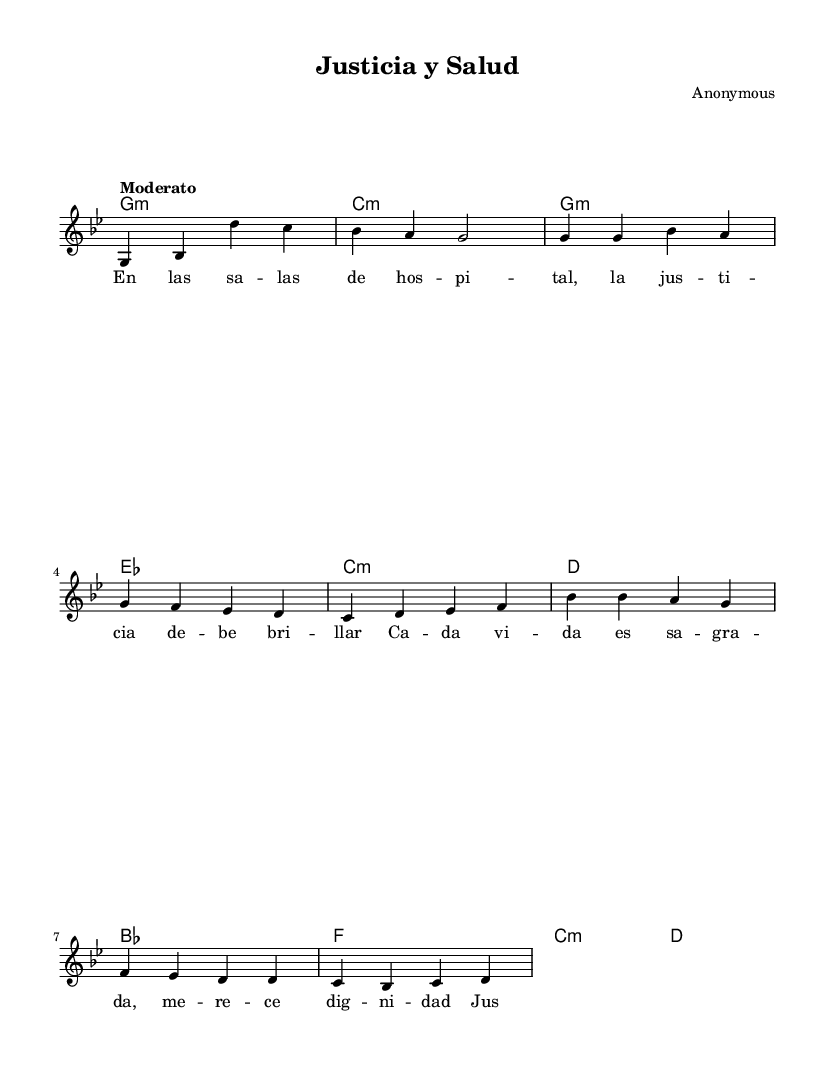What is the key signature of this music? The key signature is G minor, which has two flats (B flat and E flat) indicated right after the clef sign. This is confirmed by the "g" at the start of the global settings.
Answer: G minor What is the time signature of this piece? The time signature is 4/4, which allows for four beats in a measure, as seen in the global settings. This is typically represented in the music as a fraction (4 over 4) at the beginning of the score.
Answer: 4/4 What is the tempo marking for the piece? The tempo marking is "Moderato," meaning a moderate pace, which is indicated in the global settings of the score.
Answer: Moderato How many measures are in the verse section? There are six measures in the verse section, as counted from the melody provided under the verse marking. The melodic line clearly outlines each measure divided by vertical bars.
Answer: Six What is the primary theme of the lyrics? The primary theme of the lyrics focuses on justice and dignity in healthcare, as indicated in both the verse and chorus sections. The lyrics describe the importance of healthcare rights and human dignity.
Answer: Justice and dignity Which musical section contains the most lines of lyrics? The verse section contains the most lines of lyrics, providing a detailed narrative compared to the chorus, which is shorter and repeats fewer lines. The structure of the song with more lyrics in the verse emphasizes the storytelling aspect typical of nueva canción.
Answer: Verse What social issue does this song primarily address? The song primarily addresses healthcare and justice, as highlighted in the chorus with a clear call for the protection of human rights and the dignity of life. The lyrical content reflects a commitment to social issues relevant to the audience it aims to connect with.
Answer: Healthcare and justice 